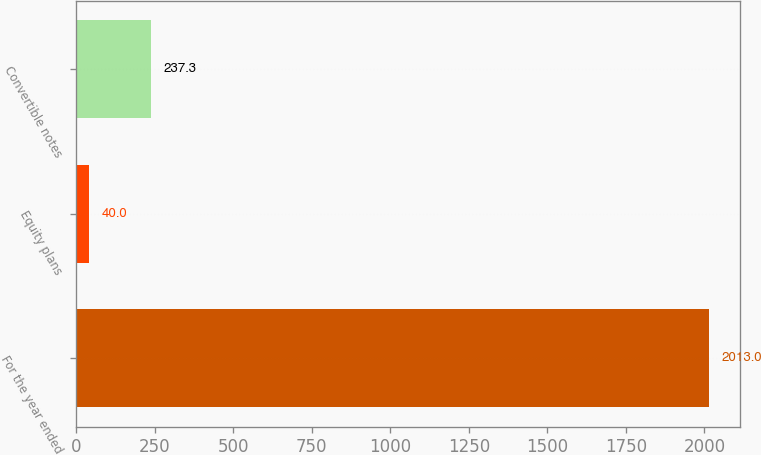<chart> <loc_0><loc_0><loc_500><loc_500><bar_chart><fcel>For the year ended<fcel>Equity plans<fcel>Convertible notes<nl><fcel>2013<fcel>40<fcel>237.3<nl></chart> 